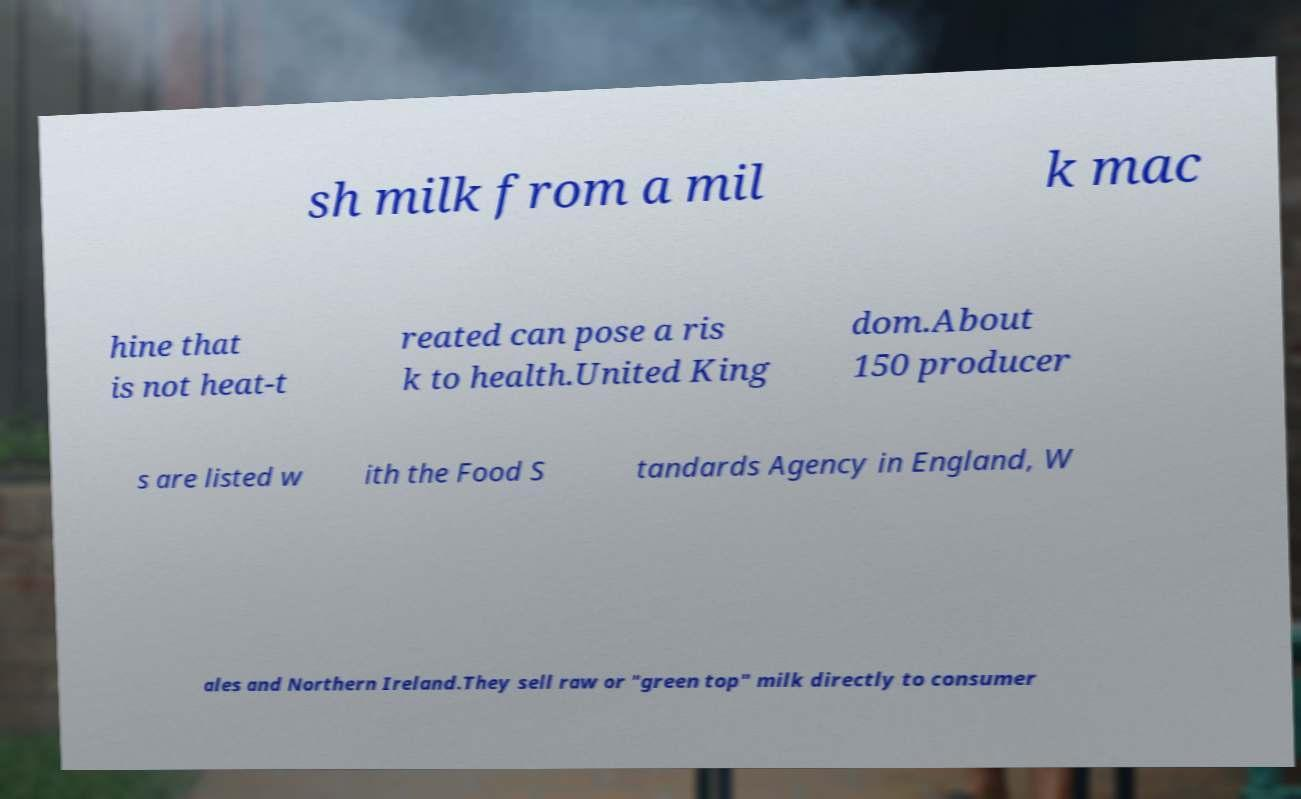There's text embedded in this image that I need extracted. Can you transcribe it verbatim? sh milk from a mil k mac hine that is not heat-t reated can pose a ris k to health.United King dom.About 150 producer s are listed w ith the Food S tandards Agency in England, W ales and Northern Ireland.They sell raw or "green top" milk directly to consumer 